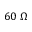Convert formula to latex. <formula><loc_0><loc_0><loc_500><loc_500>6 0 \ \Omega</formula> 